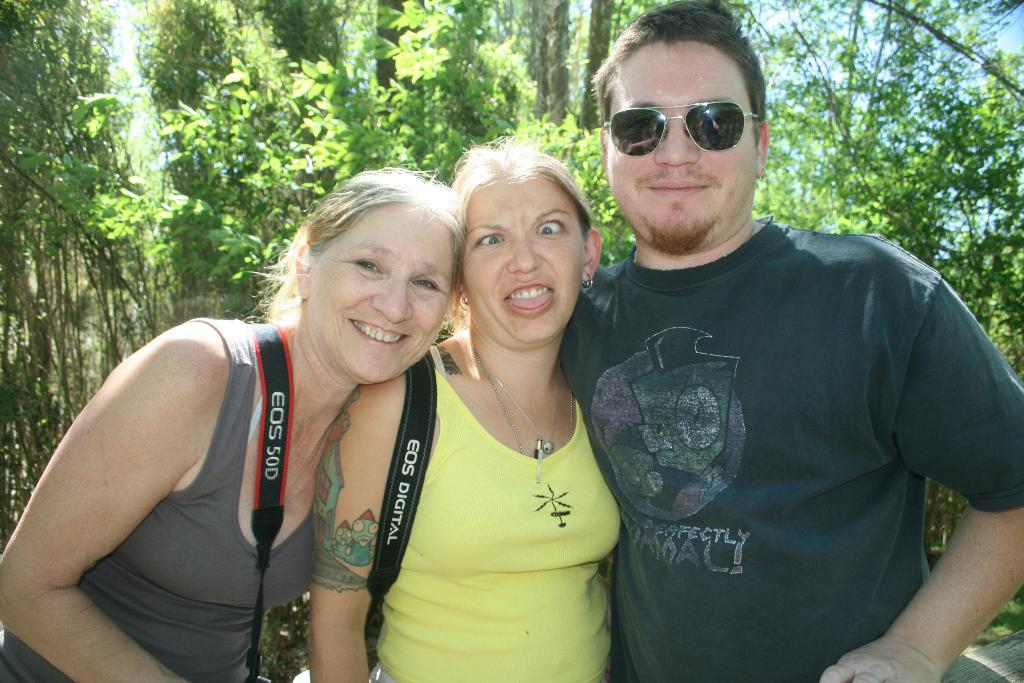How many people are present in the image? There is a man and two women in the image. What can be seen in the background of the image? There are trees and the sky visible in the background of the image. What type of tin is being used by the porter in the image? There is no porter present in the image, and therefore no tin being used. What type of plantation can be seen in the background of the image? There is no plantation visible in the image; only trees and the sky are present in the background. 